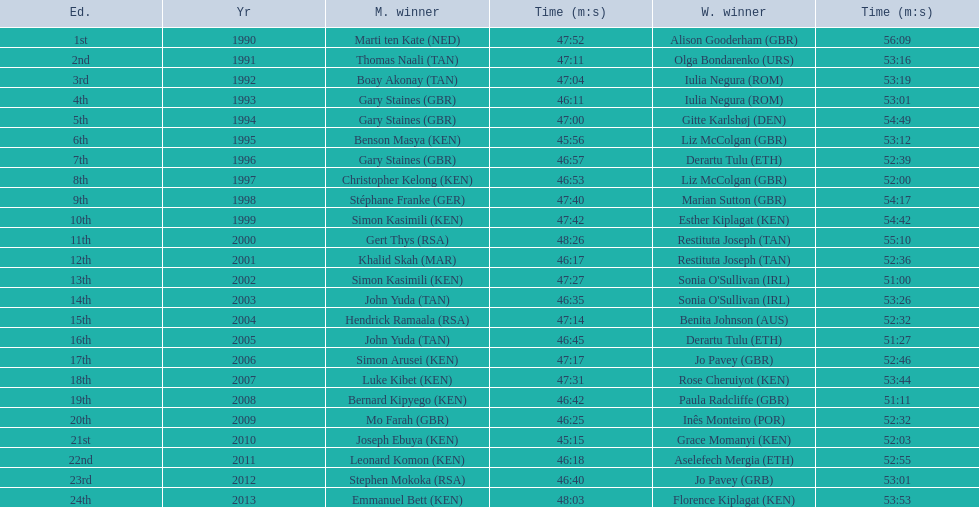What are the names of each male winner? Marti ten Kate (NED), Thomas Naali (TAN), Boay Akonay (TAN), Gary Staines (GBR), Gary Staines (GBR), Benson Masya (KEN), Gary Staines (GBR), Christopher Kelong (KEN), Stéphane Franke (GER), Simon Kasimili (KEN), Gert Thys (RSA), Khalid Skah (MAR), Simon Kasimili (KEN), John Yuda (TAN), Hendrick Ramaala (RSA), John Yuda (TAN), Simon Arusei (KEN), Luke Kibet (KEN), Bernard Kipyego (KEN), Mo Farah (GBR), Joseph Ebuya (KEN), Leonard Komon (KEN), Stephen Mokoka (RSA), Emmanuel Bett (KEN). When did they race? 1990, 1991, 1992, 1993, 1994, 1995, 1996, 1997, 1998, 1999, 2000, 2001, 2002, 2003, 2004, 2005, 2006, 2007, 2008, 2009, 2010, 2011, 2012, 2013. And what were their times? 47:52, 47:11, 47:04, 46:11, 47:00, 45:56, 46:57, 46:53, 47:40, 47:42, 48:26, 46:17, 47:27, 46:35, 47:14, 46:45, 47:17, 47:31, 46:42, 46:25, 45:15, 46:18, 46:40, 48:03. Of those times, which athlete had the fastest time? Joseph Ebuya (KEN). 